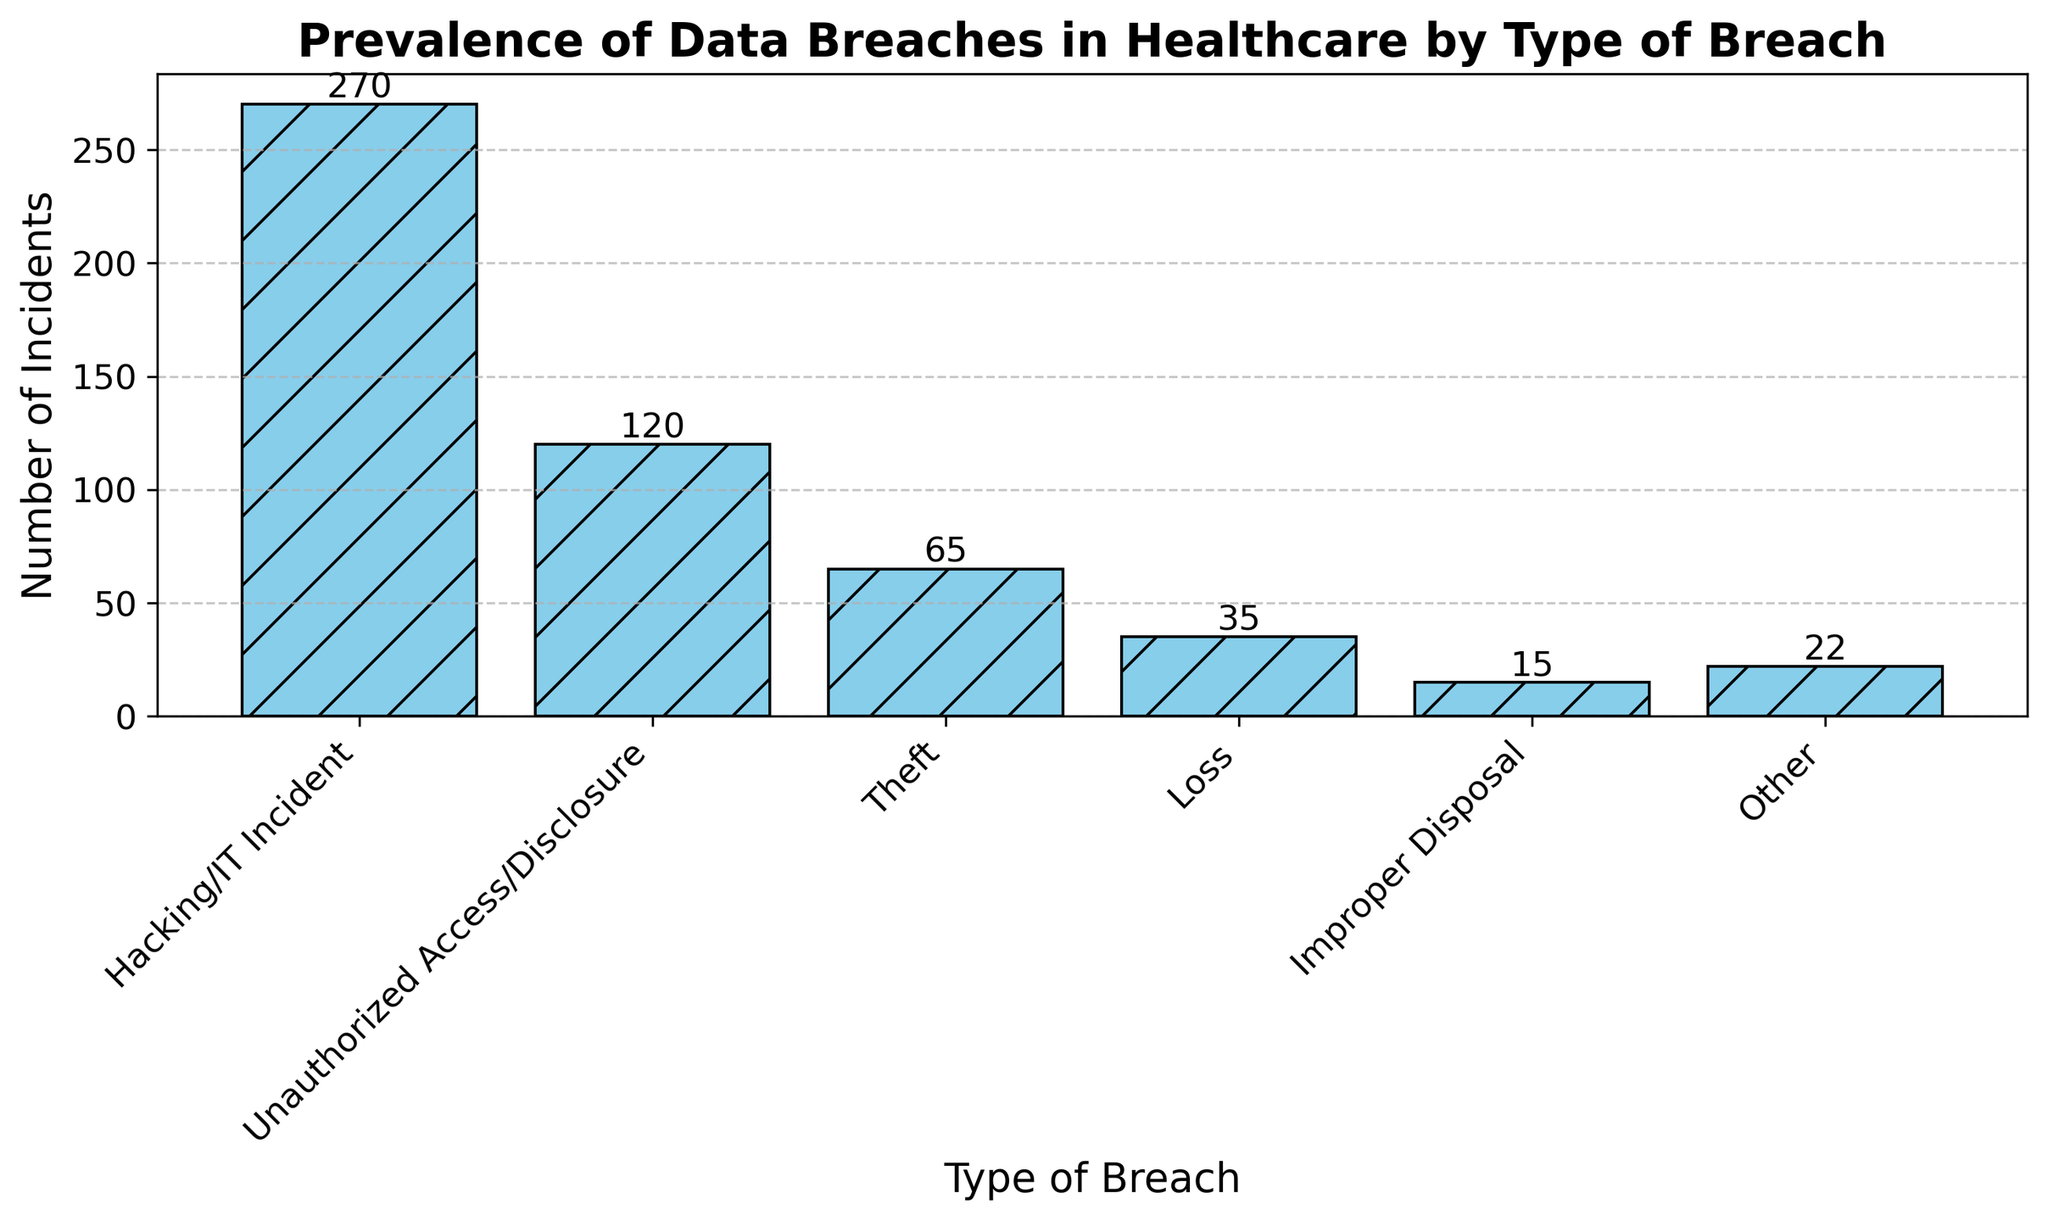What is the total number of incidents across all types of breaches? Sum the numbers from all the bars: 270 (Hacking/IT Incident) + 120 (Unauthorized Access/Disclosure) + 65 (Theft) + 35 (Loss) + 15 (Improper Disposal) + 22 (Other). Total is 270 + 120 + 65 + 35 + 15 + 22 = 527.
Answer: 527 Which type of breach has the highest number of incidents? Compare the heights of all the bars. The bar labeled "Hacking/IT Incident" is the tallest with 270 incidents.
Answer: Hacking/IT Incident How many more incidents are there for hacking/IT incidents compared to unauthorized access/disclosure? Subtract the number of incidents of Unauthorized Access/Disclosure from Hacking/IT Incident: 270 - 120 = 150.
Answer: 150 What is the average number of incidents for Theft, Loss, and Improper Disposal combined? Add the numbers for Theft, Loss, and Improper Disposal: 65 (Theft) + 35 (Loss) + 15 (Improper Disposal) = 115. Divide by the number of types: 115 / 3 ≈ 38.33.
Answer: 38.33 Which type of breach has the lowest number of incidents? Compare the heights of all the bars. The bar labeled "Improper Disposal" is the shortest with 15 incidents.
Answer: Improper Disposal Are there more total incidents of Theft and Loss combined than Unauthorized Access/Disclosure? Add the numbers for Theft and Loss: 65 (Theft) + 35 (Loss) = 100. Compare 100 with Unauthorized Access/Disclosure: 100 < 120.
Answer: No What is the combined percentage of Theft and Loss incidents relative to the total number of incidents? Calculate the total number of incidents: 527. Then, sum Theft and Loss: 65 + 35 = 100. Use the formula (100 / 527) * 100 ≈ 18.98%.
Answer: 18.98% Which type of breach incident count is exactly double that of another type? Compare the numbers of incidents: 15 <-> 30, 22 <-> 44 (only 15 for Improper Disposal and 30 for none). None of the counts are exactly double another type.
Answer: None Which type of breach sees close to a third of the total incidents? Total number of incidents is 527. A third of this is approximately 527 / 3 ≈ 175.67. Compare each type to this value. "Unauthorized Access/Disclosure" with 120 incidents is closest.
Answer: Unauthorized Access/Disclosure 